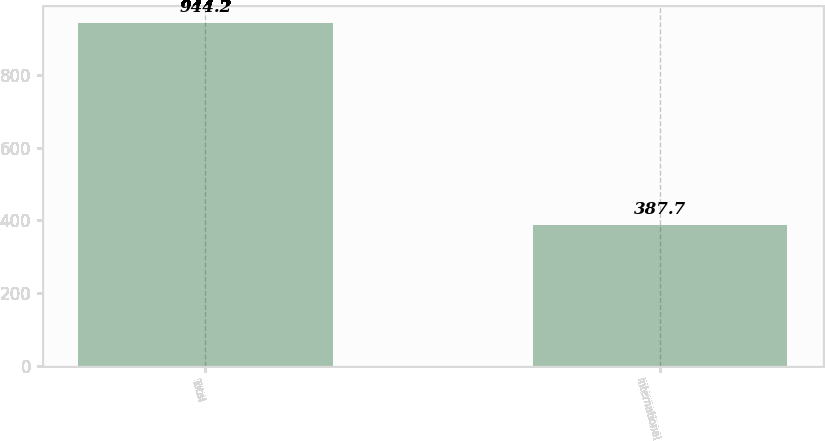<chart> <loc_0><loc_0><loc_500><loc_500><bar_chart><fcel>Total<fcel>International<nl><fcel>944.2<fcel>387.7<nl></chart> 